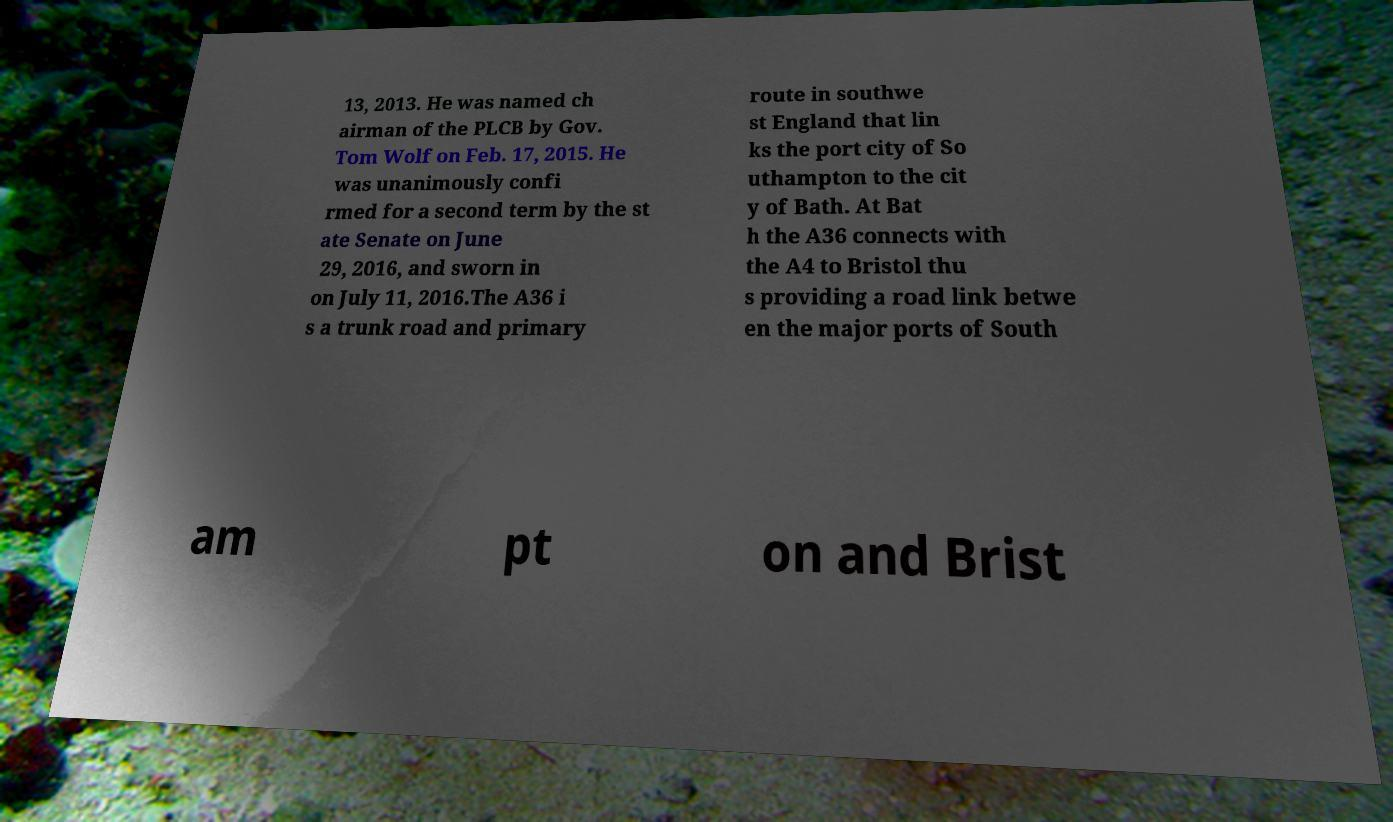Could you extract and type out the text from this image? 13, 2013. He was named ch airman of the PLCB by Gov. Tom Wolf on Feb. 17, 2015. He was unanimously confi rmed for a second term by the st ate Senate on June 29, 2016, and sworn in on July 11, 2016.The A36 i s a trunk road and primary route in southwe st England that lin ks the port city of So uthampton to the cit y of Bath. At Bat h the A36 connects with the A4 to Bristol thu s providing a road link betwe en the major ports of South am pt on and Brist 